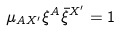<formula> <loc_0><loc_0><loc_500><loc_500>\mu _ { A X ^ { \prime } } \xi ^ { A } \bar { \xi } ^ { X ^ { \prime } } = 1</formula> 